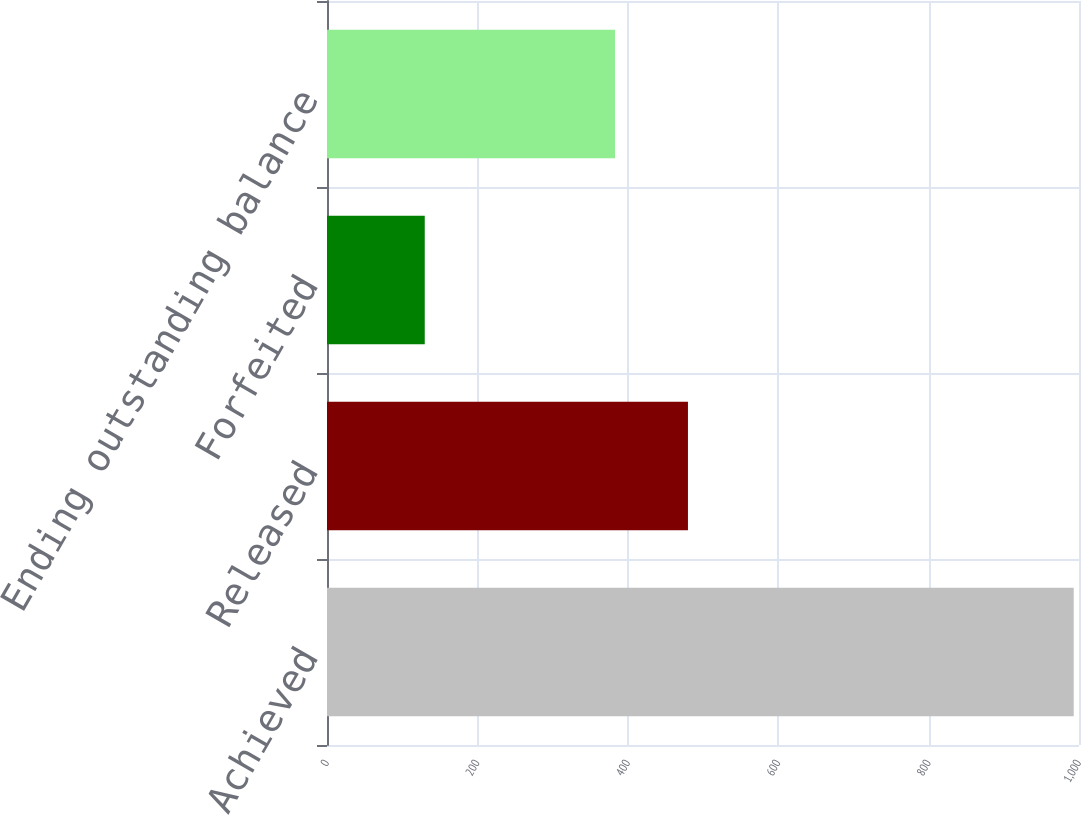Convert chart. <chart><loc_0><loc_0><loc_500><loc_500><bar_chart><fcel>Achieved<fcel>Released<fcel>Forfeited<fcel>Ending outstanding balance<nl><fcel>993<fcel>480<fcel>130<fcel>383<nl></chart> 